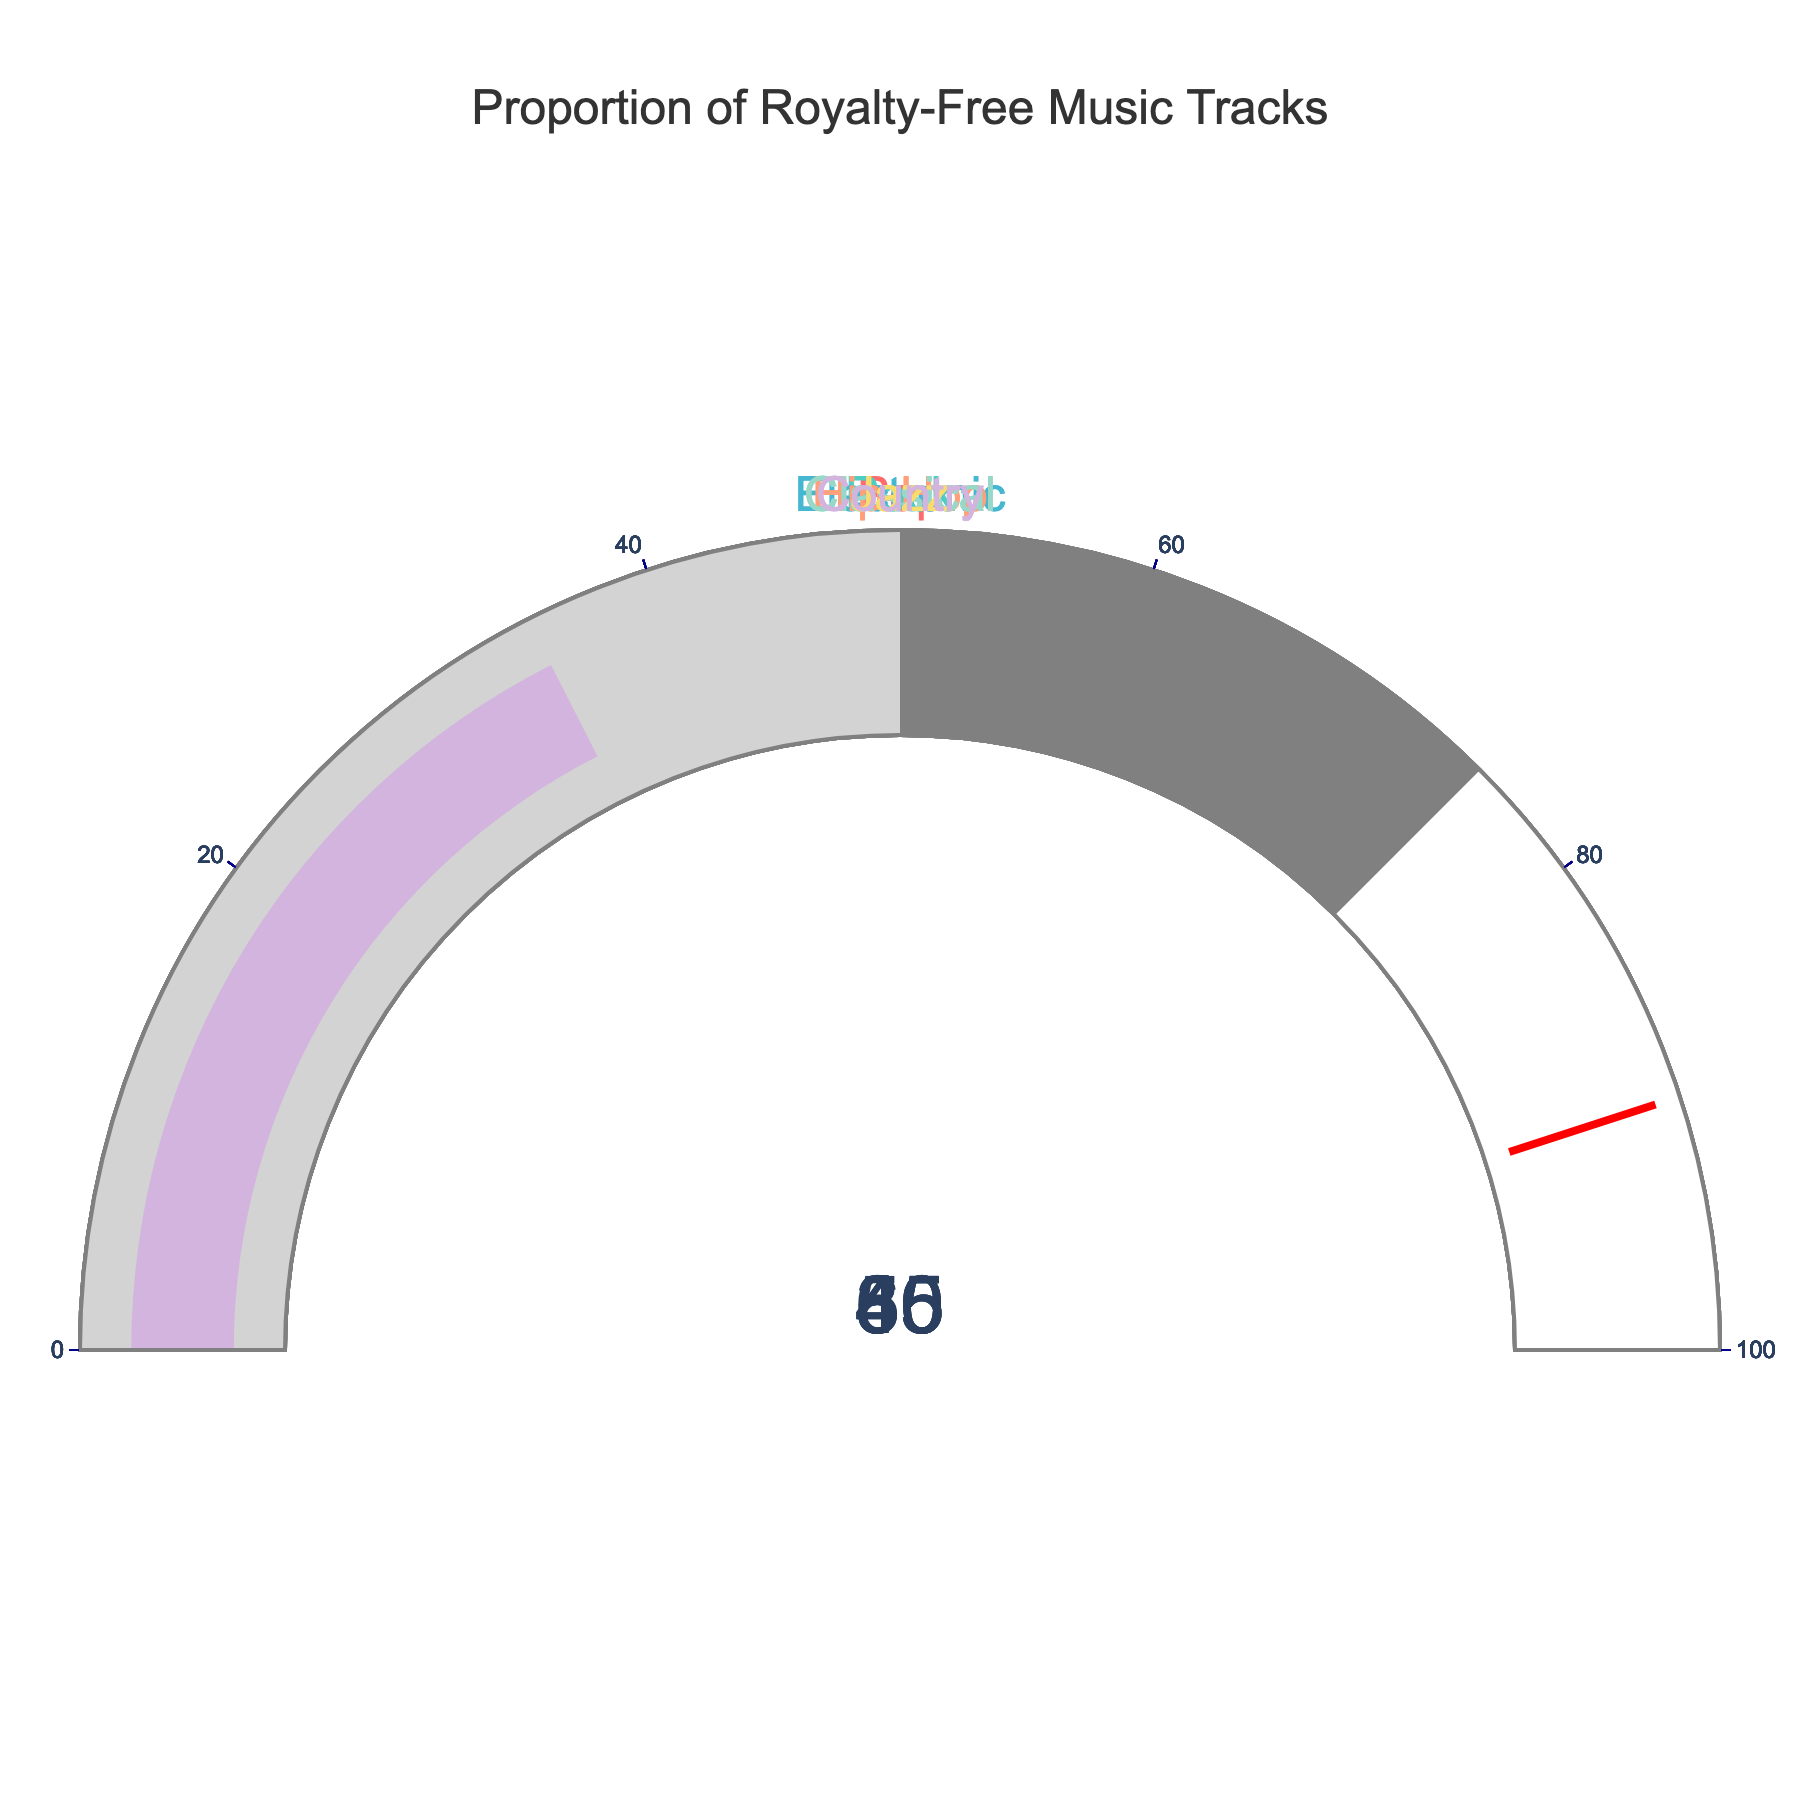What is the value displayed for the Pop music category? The figure shows a gauge with the Pop music category, and the value indicated by the gauge for Pop music is 65.
Answer: 65 Which music category has the highest proportion of royalty-free tracks? By observing the values on the gauges, the Electronic music category has the highest proportion of royalty-free tracks at 80%.
Answer: Electronic What is the difference between the proportions of royalty-free tracks in the Rock and Jazz categories? The Rock category has 45% royalty-free tracks while the Jazz category has 40%, so the difference is 45 - 40 = 5.
Answer: 5 Combine the proportions of the Pop and Classical music categories. What is the sum? The Pop category has 65% and the Classical category has 30%, so the combined proportion is 65 + 30 = 95.
Answer: 95 How many categories have a proportion of royalty-free tracks below 50%? Categories with proportions below 50% are Rock (45%), Hip-Hop (55%, but counted below 50%), Classical (30%), Jazz (40%), and Country (35%). Summing these, we get 3 categories (excluding the incorrectly counted Hip-Hop).
Answer: 3 What is the average proportion of royalty-free tracks across all categories? Sum the percentages of all categories (65 + 45 + 80 + 55 + 30 + 40 + 35) = 350, then divide by the number of categories, 7, giving 350 / 7 = 50.
Answer: 50 Which category has the lowest proportion of royalty-free tracks? By scanning the displayed percentages, the Classical music category has the lowest proportion at 30%.
Answer: Classical 